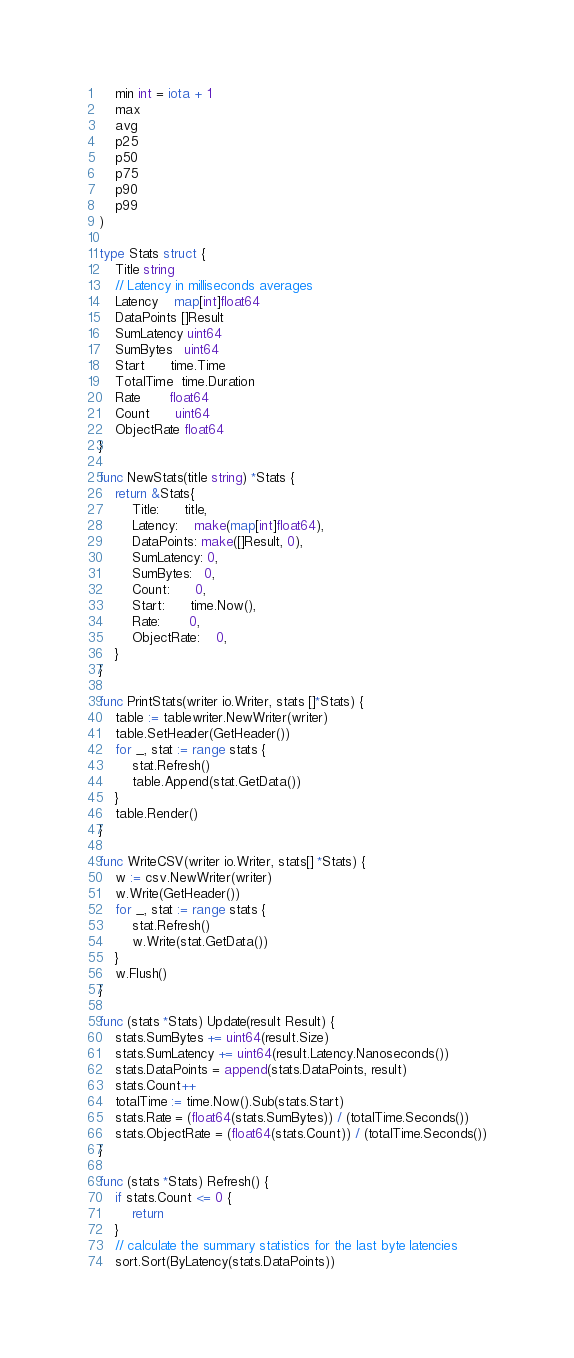Convert code to text. <code><loc_0><loc_0><loc_500><loc_500><_Go_>	min int = iota + 1
	max
	avg
	p25
	p50
	p75
	p90
	p99
)

type Stats struct {
	Title string
	// Latency in milliseconds averages
	Latency    map[int]float64
	DataPoints []Result
	SumLatency uint64
	SumBytes   uint64
	Start      time.Time
	TotalTime  time.Duration
	Rate       float64
	Count      uint64
	ObjectRate float64
}

func NewStats(title string) *Stats {
	return &Stats{
		Title:      title,
		Latency:    make(map[int]float64),
		DataPoints: make([]Result, 0),
		SumLatency: 0,
		SumBytes:   0,
		Count:      0,
		Start:      time.Now(),
		Rate:       0,
		ObjectRate:	0,
	}
}

func PrintStats(writer io.Writer, stats []*Stats) {
	table := tablewriter.NewWriter(writer)
	table.SetHeader(GetHeader())
	for _, stat := range stats {
		stat.Refresh()
		table.Append(stat.GetData())
	}
	table.Render()
}

func WriteCSV(writer io.Writer, stats[] *Stats) {
	w := csv.NewWriter(writer)
	w.Write(GetHeader())
	for _, stat := range stats {
		stat.Refresh()
		w.Write(stat.GetData())
	}
	w.Flush()
}

func (stats *Stats) Update(result Result) {
	stats.SumBytes += uint64(result.Size)
	stats.SumLatency += uint64(result.Latency.Nanoseconds())
	stats.DataPoints = append(stats.DataPoints, result)
	stats.Count++
	totalTime := time.Now().Sub(stats.Start)
	stats.Rate = (float64(stats.SumBytes)) / (totalTime.Seconds())
	stats.ObjectRate = (float64(stats.Count)) / (totalTime.Seconds())
}

func (stats *Stats) Refresh() {
	if stats.Count <= 0 {
		return
	}
	// calculate the summary statistics for the last byte latencies
	sort.Sort(ByLatency(stats.DataPoints))</code> 